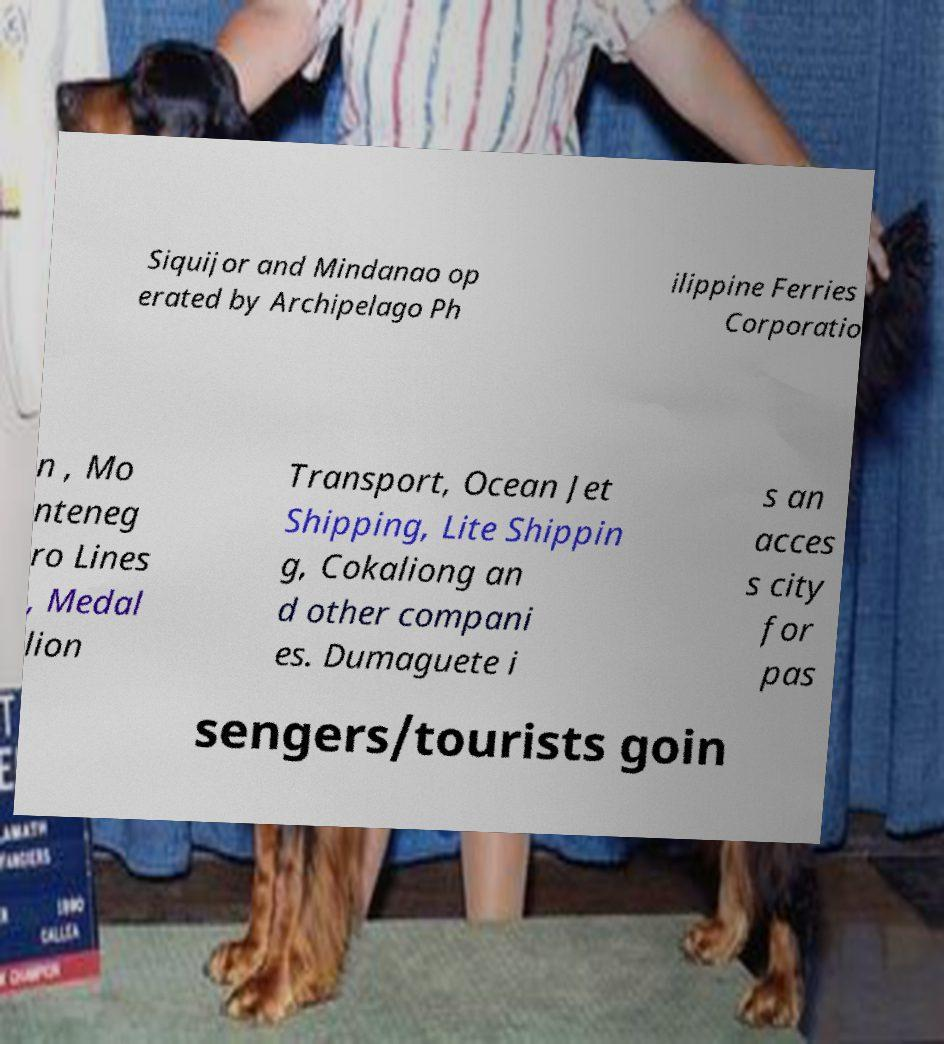For documentation purposes, I need the text within this image transcribed. Could you provide that? Siquijor and Mindanao op erated by Archipelago Ph ilippine Ferries Corporatio n , Mo nteneg ro Lines , Medal lion Transport, Ocean Jet Shipping, Lite Shippin g, Cokaliong an d other compani es. Dumaguete i s an acces s city for pas sengers/tourists goin 